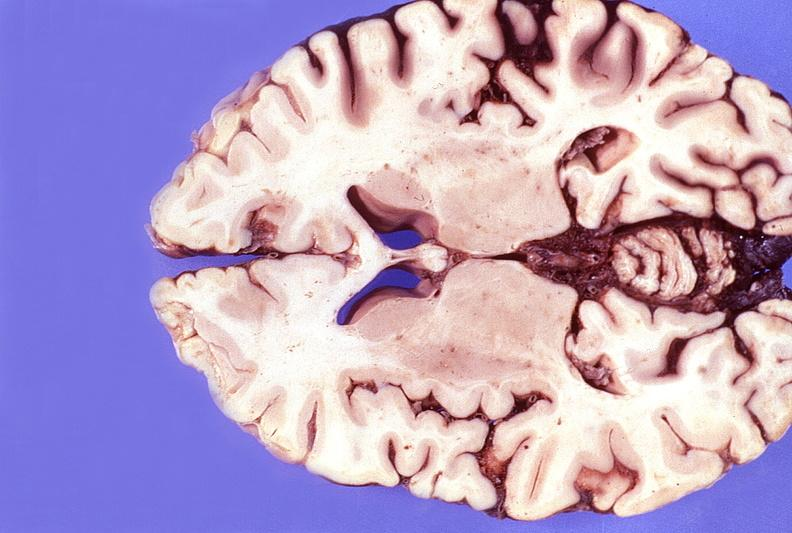s nervous present?
Answer the question using a single word or phrase. Yes 